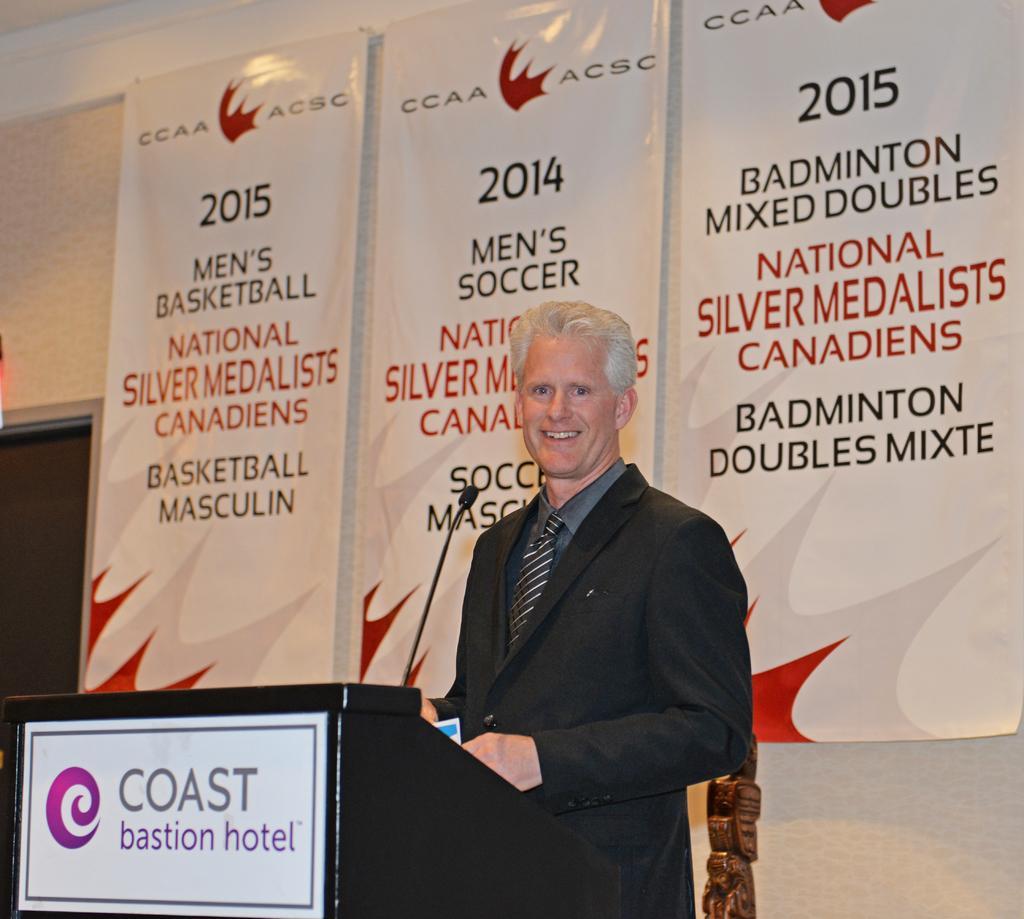Describe this image in one or two sentences. In this picture there is a man who is standing in the center of the image and there is a desk and a mic in front of him and there are posters in the background area of the image. 